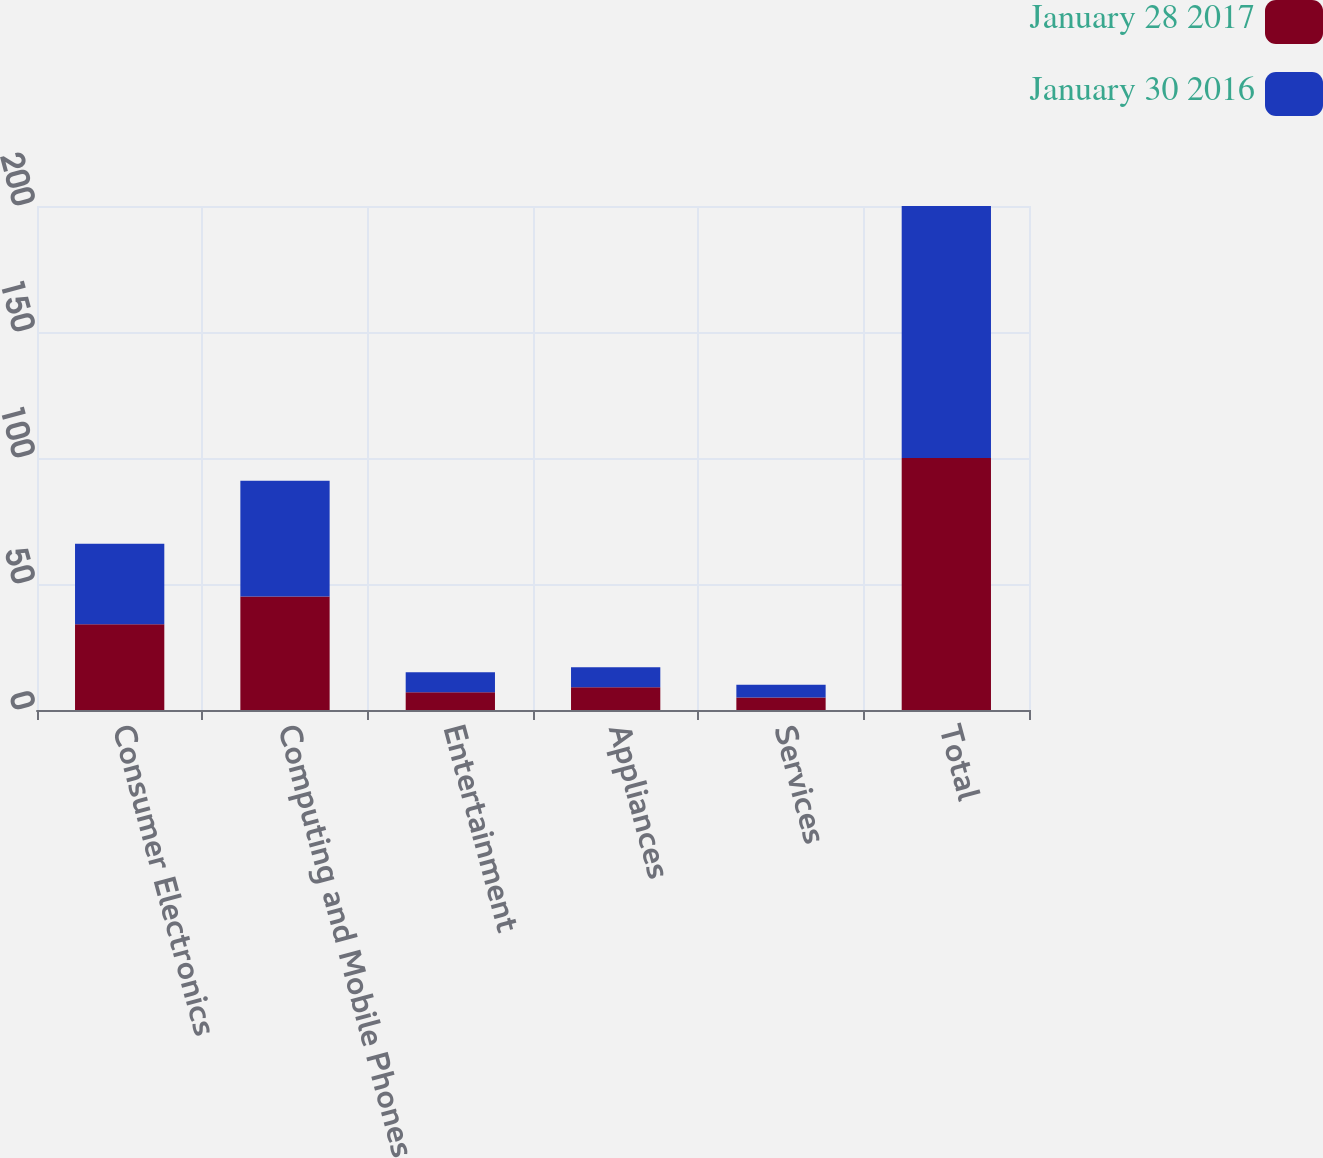Convert chart. <chart><loc_0><loc_0><loc_500><loc_500><stacked_bar_chart><ecel><fcel>Consumer Electronics<fcel>Computing and Mobile Phones<fcel>Entertainment<fcel>Appliances<fcel>Services<fcel>Total<nl><fcel>January 28 2017<fcel>34<fcel>45<fcel>7<fcel>9<fcel>5<fcel>100<nl><fcel>January 30 2016<fcel>32<fcel>46<fcel>8<fcel>8<fcel>5<fcel>100<nl></chart> 